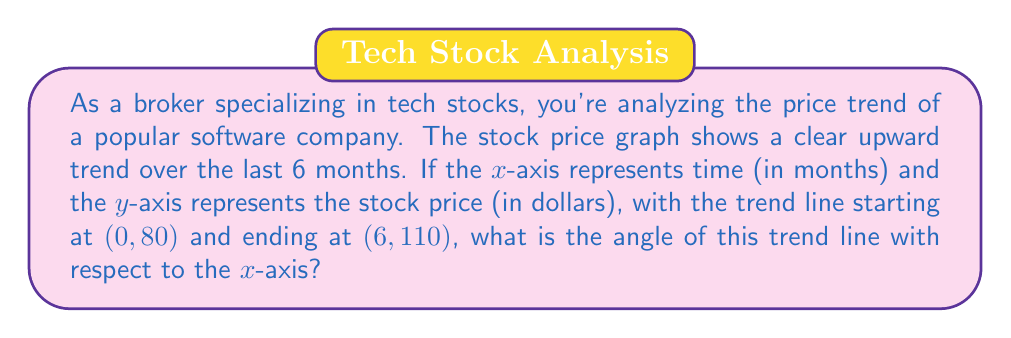Can you answer this question? To solve this problem, we need to follow these steps:

1. Identify the rise and run of the trend line:
   - Rise = Change in y = $110 - 80 = 30$ dollars
   - Run = Change in x = $6 - 0 = 6$ months

2. Calculate the slope of the trend line:
   $$ m = \frac{\text{rise}}{\text{run}} = \frac{30}{6} = 5 $$

3. Use the arctangent function to find the angle:
   The angle θ of the trend line with respect to the x-axis is given by:
   $$ \theta = \arctan(m) $$

4. Calculate the angle:
   $$ \theta = \arctan(5) $$

5. Convert the result from radians to degrees:
   $$ \theta = \arctan(5) \cdot \frac{180°}{\pi} $$

[asy]
import geometry;

size(200);
real angle = atan(5);
draw((0,0)--(6,0), arrow=Arrow(TeXHead));
draw((0,0)--(0,4), arrow=Arrow(TeXHead));
draw((0,0)--(6,5), p=red+1);
label("$x$ (months)", (6,0), S);
label("$y$ (price)", (0,4), W);
label("$\theta$", (0.5,0.5), NW);
draw(arc((0,0),0.5,0,degrees(angle)), blue);
[/asy]
Answer: $$ \theta \approx 78.69° $$ 